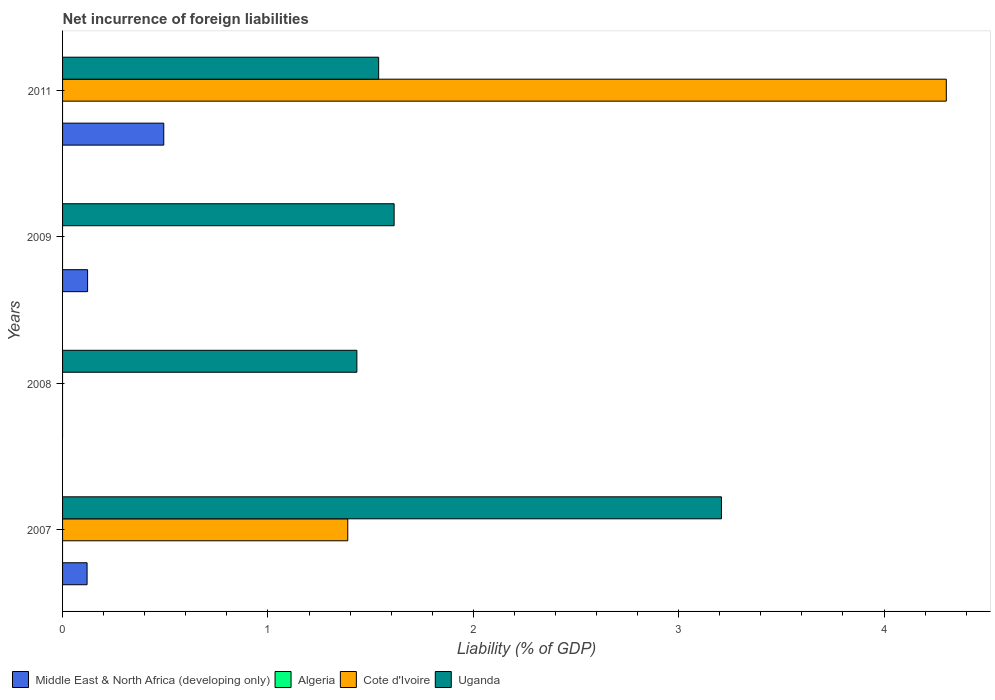How many different coloured bars are there?
Offer a very short reply. 3. Are the number of bars on each tick of the Y-axis equal?
Make the answer very short. No. How many bars are there on the 2nd tick from the top?
Your answer should be very brief. 2. How many bars are there on the 2nd tick from the bottom?
Your answer should be very brief. 1. In how many cases, is the number of bars for a given year not equal to the number of legend labels?
Your answer should be compact. 4. What is the net incurrence of foreign liabilities in Algeria in 2008?
Your answer should be very brief. 0. Across all years, what is the maximum net incurrence of foreign liabilities in Middle East & North Africa (developing only)?
Your answer should be very brief. 0.49. Across all years, what is the minimum net incurrence of foreign liabilities in Algeria?
Provide a succinct answer. 0. What is the difference between the net incurrence of foreign liabilities in Uganda in 2007 and that in 2008?
Provide a succinct answer. 1.78. What is the difference between the net incurrence of foreign liabilities in Cote d'Ivoire in 2011 and the net incurrence of foreign liabilities in Uganda in 2008?
Provide a short and direct response. 2.87. What is the average net incurrence of foreign liabilities in Algeria per year?
Your response must be concise. 0. In the year 2011, what is the difference between the net incurrence of foreign liabilities in Middle East & North Africa (developing only) and net incurrence of foreign liabilities in Uganda?
Provide a short and direct response. -1.05. What is the ratio of the net incurrence of foreign liabilities in Uganda in 2008 to that in 2011?
Your response must be concise. 0.93. Is the net incurrence of foreign liabilities in Cote d'Ivoire in 2007 less than that in 2011?
Ensure brevity in your answer.  Yes. Is the difference between the net incurrence of foreign liabilities in Middle East & North Africa (developing only) in 2007 and 2009 greater than the difference between the net incurrence of foreign liabilities in Uganda in 2007 and 2009?
Your answer should be very brief. No. What is the difference between the highest and the second highest net incurrence of foreign liabilities in Middle East & North Africa (developing only)?
Keep it short and to the point. 0.37. What is the difference between the highest and the lowest net incurrence of foreign liabilities in Middle East & North Africa (developing only)?
Offer a terse response. 0.49. In how many years, is the net incurrence of foreign liabilities in Cote d'Ivoire greater than the average net incurrence of foreign liabilities in Cote d'Ivoire taken over all years?
Ensure brevity in your answer.  1. Is it the case that in every year, the sum of the net incurrence of foreign liabilities in Cote d'Ivoire and net incurrence of foreign liabilities in Uganda is greater than the sum of net incurrence of foreign liabilities in Middle East & North Africa (developing only) and net incurrence of foreign liabilities in Algeria?
Provide a short and direct response. No. Is it the case that in every year, the sum of the net incurrence of foreign liabilities in Cote d'Ivoire and net incurrence of foreign liabilities in Middle East & North Africa (developing only) is greater than the net incurrence of foreign liabilities in Algeria?
Offer a terse response. No. How many years are there in the graph?
Your answer should be very brief. 4. Where does the legend appear in the graph?
Ensure brevity in your answer.  Bottom left. How are the legend labels stacked?
Ensure brevity in your answer.  Horizontal. What is the title of the graph?
Ensure brevity in your answer.  Net incurrence of foreign liabilities. Does "Liechtenstein" appear as one of the legend labels in the graph?
Make the answer very short. No. What is the label or title of the X-axis?
Your answer should be compact. Liability (% of GDP). What is the Liability (% of GDP) of Middle East & North Africa (developing only) in 2007?
Make the answer very short. 0.12. What is the Liability (% of GDP) in Algeria in 2007?
Ensure brevity in your answer.  0. What is the Liability (% of GDP) of Cote d'Ivoire in 2007?
Keep it short and to the point. 1.39. What is the Liability (% of GDP) in Uganda in 2007?
Offer a terse response. 3.21. What is the Liability (% of GDP) in Middle East & North Africa (developing only) in 2008?
Your answer should be very brief. 0. What is the Liability (% of GDP) of Algeria in 2008?
Your answer should be very brief. 0. What is the Liability (% of GDP) in Cote d'Ivoire in 2008?
Offer a terse response. 0. What is the Liability (% of GDP) in Uganda in 2008?
Your response must be concise. 1.43. What is the Liability (% of GDP) of Middle East & North Africa (developing only) in 2009?
Offer a terse response. 0.12. What is the Liability (% of GDP) in Uganda in 2009?
Keep it short and to the point. 1.61. What is the Liability (% of GDP) of Middle East & North Africa (developing only) in 2011?
Your response must be concise. 0.49. What is the Liability (% of GDP) of Cote d'Ivoire in 2011?
Offer a very short reply. 4.3. What is the Liability (% of GDP) of Uganda in 2011?
Ensure brevity in your answer.  1.54. Across all years, what is the maximum Liability (% of GDP) in Middle East & North Africa (developing only)?
Offer a terse response. 0.49. Across all years, what is the maximum Liability (% of GDP) of Cote d'Ivoire?
Your response must be concise. 4.3. Across all years, what is the maximum Liability (% of GDP) of Uganda?
Offer a terse response. 3.21. Across all years, what is the minimum Liability (% of GDP) of Middle East & North Africa (developing only)?
Offer a very short reply. 0. Across all years, what is the minimum Liability (% of GDP) of Uganda?
Your response must be concise. 1.43. What is the total Liability (% of GDP) in Middle East & North Africa (developing only) in the graph?
Provide a succinct answer. 0.73. What is the total Liability (% of GDP) in Algeria in the graph?
Your answer should be compact. 0. What is the total Liability (% of GDP) of Cote d'Ivoire in the graph?
Your answer should be very brief. 5.69. What is the total Liability (% of GDP) in Uganda in the graph?
Your answer should be compact. 7.79. What is the difference between the Liability (% of GDP) in Uganda in 2007 and that in 2008?
Your answer should be very brief. 1.78. What is the difference between the Liability (% of GDP) in Middle East & North Africa (developing only) in 2007 and that in 2009?
Give a very brief answer. -0. What is the difference between the Liability (% of GDP) of Uganda in 2007 and that in 2009?
Ensure brevity in your answer.  1.59. What is the difference between the Liability (% of GDP) in Middle East & North Africa (developing only) in 2007 and that in 2011?
Make the answer very short. -0.37. What is the difference between the Liability (% of GDP) in Cote d'Ivoire in 2007 and that in 2011?
Give a very brief answer. -2.91. What is the difference between the Liability (% of GDP) of Uganda in 2007 and that in 2011?
Offer a terse response. 1.67. What is the difference between the Liability (% of GDP) of Uganda in 2008 and that in 2009?
Give a very brief answer. -0.18. What is the difference between the Liability (% of GDP) in Uganda in 2008 and that in 2011?
Your response must be concise. -0.11. What is the difference between the Liability (% of GDP) in Middle East & North Africa (developing only) in 2009 and that in 2011?
Your answer should be very brief. -0.37. What is the difference between the Liability (% of GDP) in Uganda in 2009 and that in 2011?
Your answer should be compact. 0.08. What is the difference between the Liability (% of GDP) in Middle East & North Africa (developing only) in 2007 and the Liability (% of GDP) in Uganda in 2008?
Your answer should be compact. -1.31. What is the difference between the Liability (% of GDP) of Cote d'Ivoire in 2007 and the Liability (% of GDP) of Uganda in 2008?
Your answer should be very brief. -0.04. What is the difference between the Liability (% of GDP) of Middle East & North Africa (developing only) in 2007 and the Liability (% of GDP) of Uganda in 2009?
Provide a succinct answer. -1.5. What is the difference between the Liability (% of GDP) of Cote d'Ivoire in 2007 and the Liability (% of GDP) of Uganda in 2009?
Your answer should be compact. -0.23. What is the difference between the Liability (% of GDP) of Middle East & North Africa (developing only) in 2007 and the Liability (% of GDP) of Cote d'Ivoire in 2011?
Offer a terse response. -4.18. What is the difference between the Liability (% of GDP) in Middle East & North Africa (developing only) in 2007 and the Liability (% of GDP) in Uganda in 2011?
Provide a succinct answer. -1.42. What is the difference between the Liability (% of GDP) of Cote d'Ivoire in 2007 and the Liability (% of GDP) of Uganda in 2011?
Make the answer very short. -0.15. What is the difference between the Liability (% of GDP) in Middle East & North Africa (developing only) in 2009 and the Liability (% of GDP) in Cote d'Ivoire in 2011?
Your response must be concise. -4.18. What is the difference between the Liability (% of GDP) of Middle East & North Africa (developing only) in 2009 and the Liability (% of GDP) of Uganda in 2011?
Ensure brevity in your answer.  -1.42. What is the average Liability (% of GDP) of Middle East & North Africa (developing only) per year?
Give a very brief answer. 0.18. What is the average Liability (% of GDP) in Algeria per year?
Provide a short and direct response. 0. What is the average Liability (% of GDP) of Cote d'Ivoire per year?
Your response must be concise. 1.42. What is the average Liability (% of GDP) in Uganda per year?
Provide a succinct answer. 1.95. In the year 2007, what is the difference between the Liability (% of GDP) of Middle East & North Africa (developing only) and Liability (% of GDP) of Cote d'Ivoire?
Your answer should be compact. -1.27. In the year 2007, what is the difference between the Liability (% of GDP) of Middle East & North Africa (developing only) and Liability (% of GDP) of Uganda?
Give a very brief answer. -3.09. In the year 2007, what is the difference between the Liability (% of GDP) in Cote d'Ivoire and Liability (% of GDP) in Uganda?
Your answer should be compact. -1.82. In the year 2009, what is the difference between the Liability (% of GDP) in Middle East & North Africa (developing only) and Liability (% of GDP) in Uganda?
Offer a very short reply. -1.49. In the year 2011, what is the difference between the Liability (% of GDP) in Middle East & North Africa (developing only) and Liability (% of GDP) in Cote d'Ivoire?
Make the answer very short. -3.81. In the year 2011, what is the difference between the Liability (% of GDP) of Middle East & North Africa (developing only) and Liability (% of GDP) of Uganda?
Ensure brevity in your answer.  -1.05. In the year 2011, what is the difference between the Liability (% of GDP) in Cote d'Ivoire and Liability (% of GDP) in Uganda?
Your answer should be very brief. 2.76. What is the ratio of the Liability (% of GDP) of Uganda in 2007 to that in 2008?
Offer a terse response. 2.24. What is the ratio of the Liability (% of GDP) of Middle East & North Africa (developing only) in 2007 to that in 2009?
Offer a terse response. 0.98. What is the ratio of the Liability (% of GDP) of Uganda in 2007 to that in 2009?
Give a very brief answer. 1.99. What is the ratio of the Liability (% of GDP) of Middle East & North Africa (developing only) in 2007 to that in 2011?
Provide a succinct answer. 0.24. What is the ratio of the Liability (% of GDP) of Cote d'Ivoire in 2007 to that in 2011?
Your answer should be compact. 0.32. What is the ratio of the Liability (% of GDP) of Uganda in 2007 to that in 2011?
Offer a very short reply. 2.08. What is the ratio of the Liability (% of GDP) in Uganda in 2008 to that in 2009?
Provide a short and direct response. 0.89. What is the ratio of the Liability (% of GDP) in Uganda in 2008 to that in 2011?
Provide a short and direct response. 0.93. What is the ratio of the Liability (% of GDP) of Middle East & North Africa (developing only) in 2009 to that in 2011?
Your answer should be compact. 0.25. What is the ratio of the Liability (% of GDP) of Uganda in 2009 to that in 2011?
Your answer should be very brief. 1.05. What is the difference between the highest and the second highest Liability (% of GDP) in Middle East & North Africa (developing only)?
Make the answer very short. 0.37. What is the difference between the highest and the second highest Liability (% of GDP) in Uganda?
Your response must be concise. 1.59. What is the difference between the highest and the lowest Liability (% of GDP) in Middle East & North Africa (developing only)?
Your answer should be very brief. 0.49. What is the difference between the highest and the lowest Liability (% of GDP) of Cote d'Ivoire?
Your response must be concise. 4.3. What is the difference between the highest and the lowest Liability (% of GDP) of Uganda?
Give a very brief answer. 1.78. 